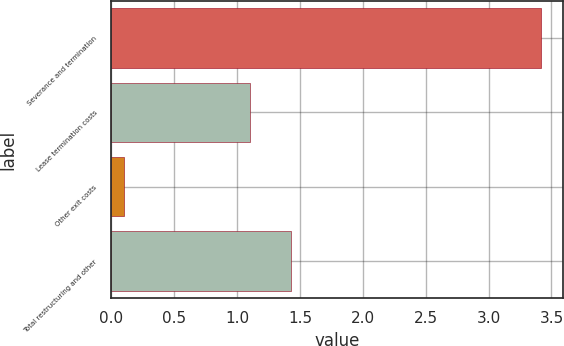<chart> <loc_0><loc_0><loc_500><loc_500><bar_chart><fcel>Severance and termination<fcel>Lease termination costs<fcel>Other exit costs<fcel>Total restructuring and other<nl><fcel>3.42<fcel>1.1<fcel>0.1<fcel>1.43<nl></chart> 